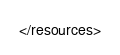<code> <loc_0><loc_0><loc_500><loc_500><_XML_></resources>
</code> 